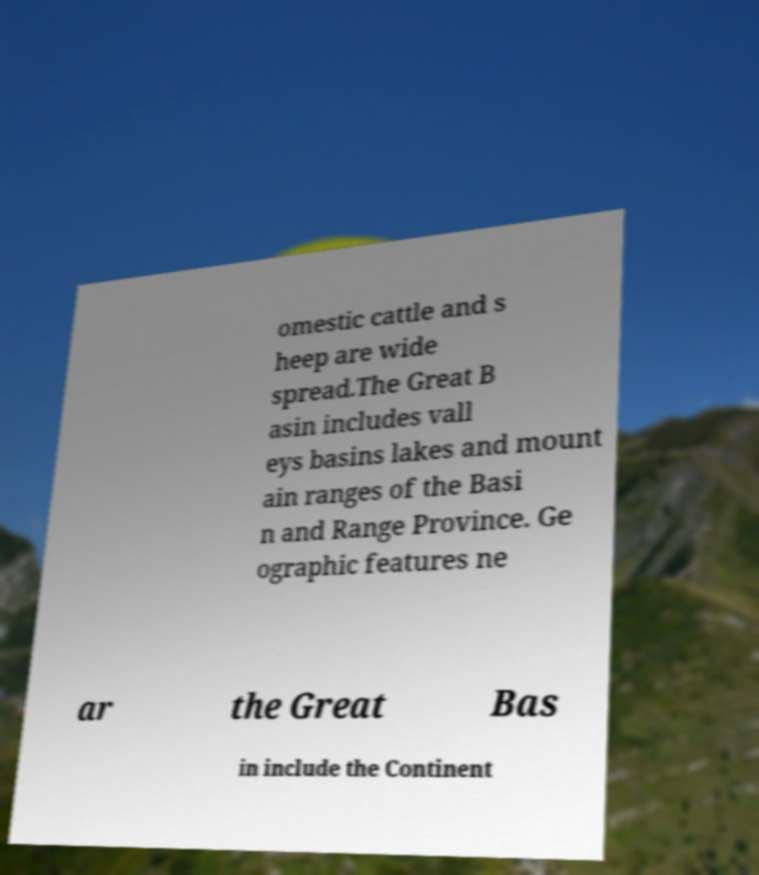Could you extract and type out the text from this image? omestic cattle and s heep are wide spread.The Great B asin includes vall eys basins lakes and mount ain ranges of the Basi n and Range Province. Ge ographic features ne ar the Great Bas in include the Continent 